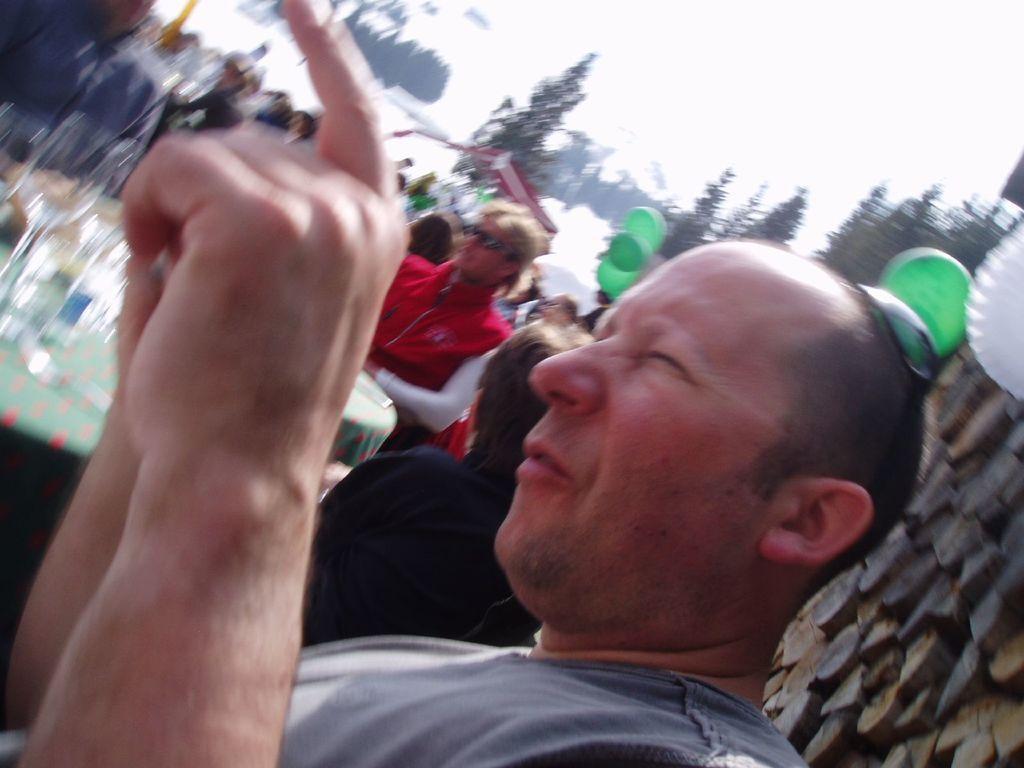Please provide a concise description of this image. In the image we can see there are many people wearing clothes. These are the balloons, trees and a sky. The background is blurred. 